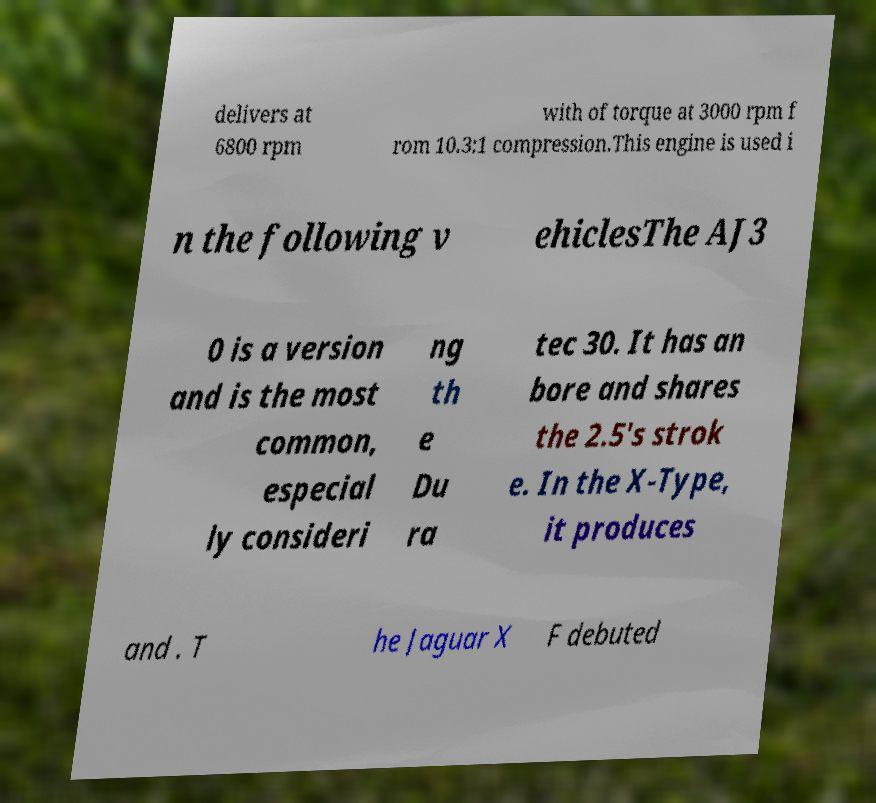Please identify and transcribe the text found in this image. delivers at 6800 rpm with of torque at 3000 rpm f rom 10.3:1 compression.This engine is used i n the following v ehiclesThe AJ3 0 is a version and is the most common, especial ly consideri ng th e Du ra tec 30. It has an bore and shares the 2.5's strok e. In the X-Type, it produces and . T he Jaguar X F debuted 